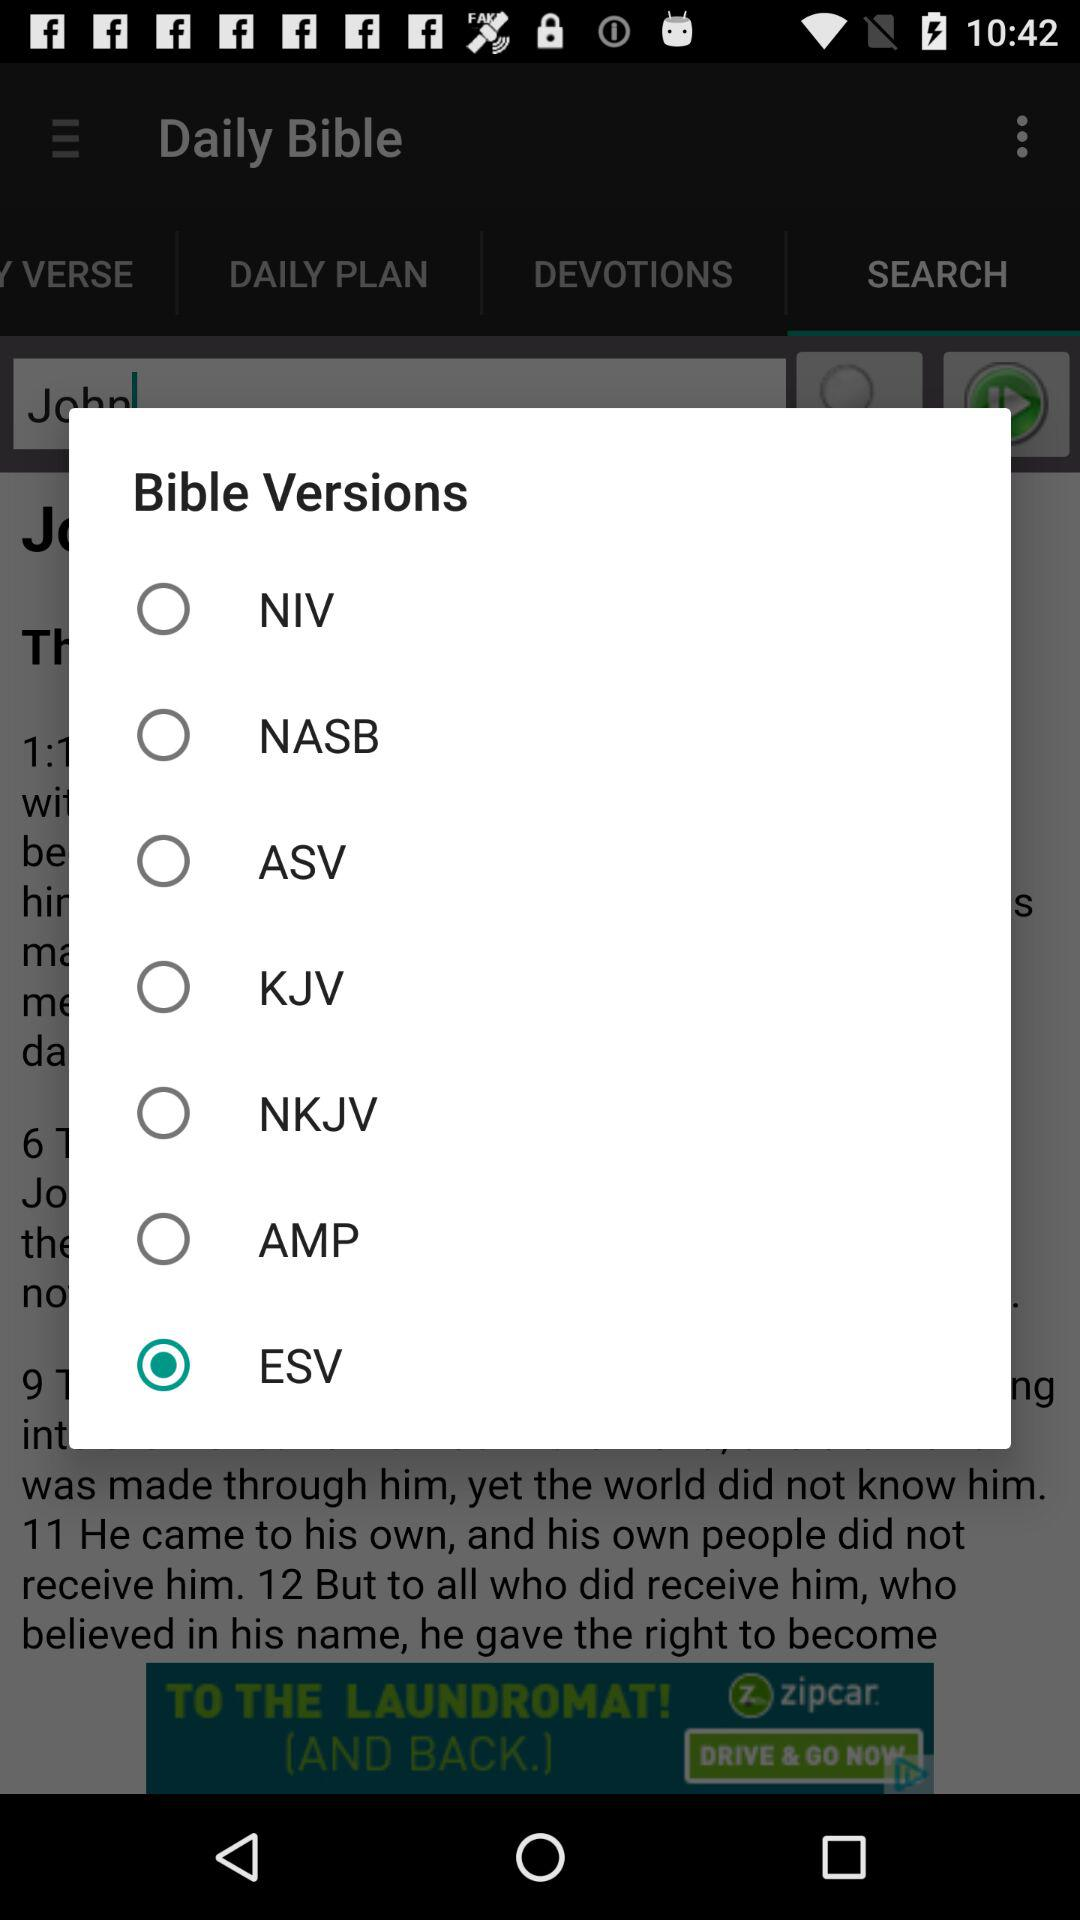Which is the selected Bible version? The selected Bible version is "ESV". 